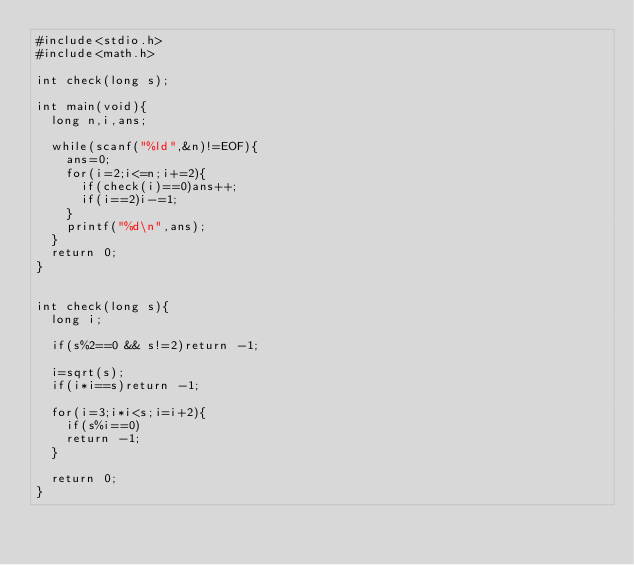<code> <loc_0><loc_0><loc_500><loc_500><_C_>#include<stdio.h>
#include<math.h>

int check(long s);

int main(void){
	long n,i,ans;
	
	while(scanf("%ld",&n)!=EOF){
		ans=0;
		for(i=2;i<=n;i+=2){
			if(check(i)==0)ans++;
			if(i==2)i-=1;
		}
		printf("%d\n",ans);
	}
	return 0;
}


int check(long s){
	long i;
	
	if(s%2==0 && s!=2)return -1;
	
	i=sqrt(s);
	if(i*i==s)return -1;
	
	for(i=3;i*i<s;i=i+2){
		if(s%i==0)
		return -1;
	}
	
	return 0;
}</code> 